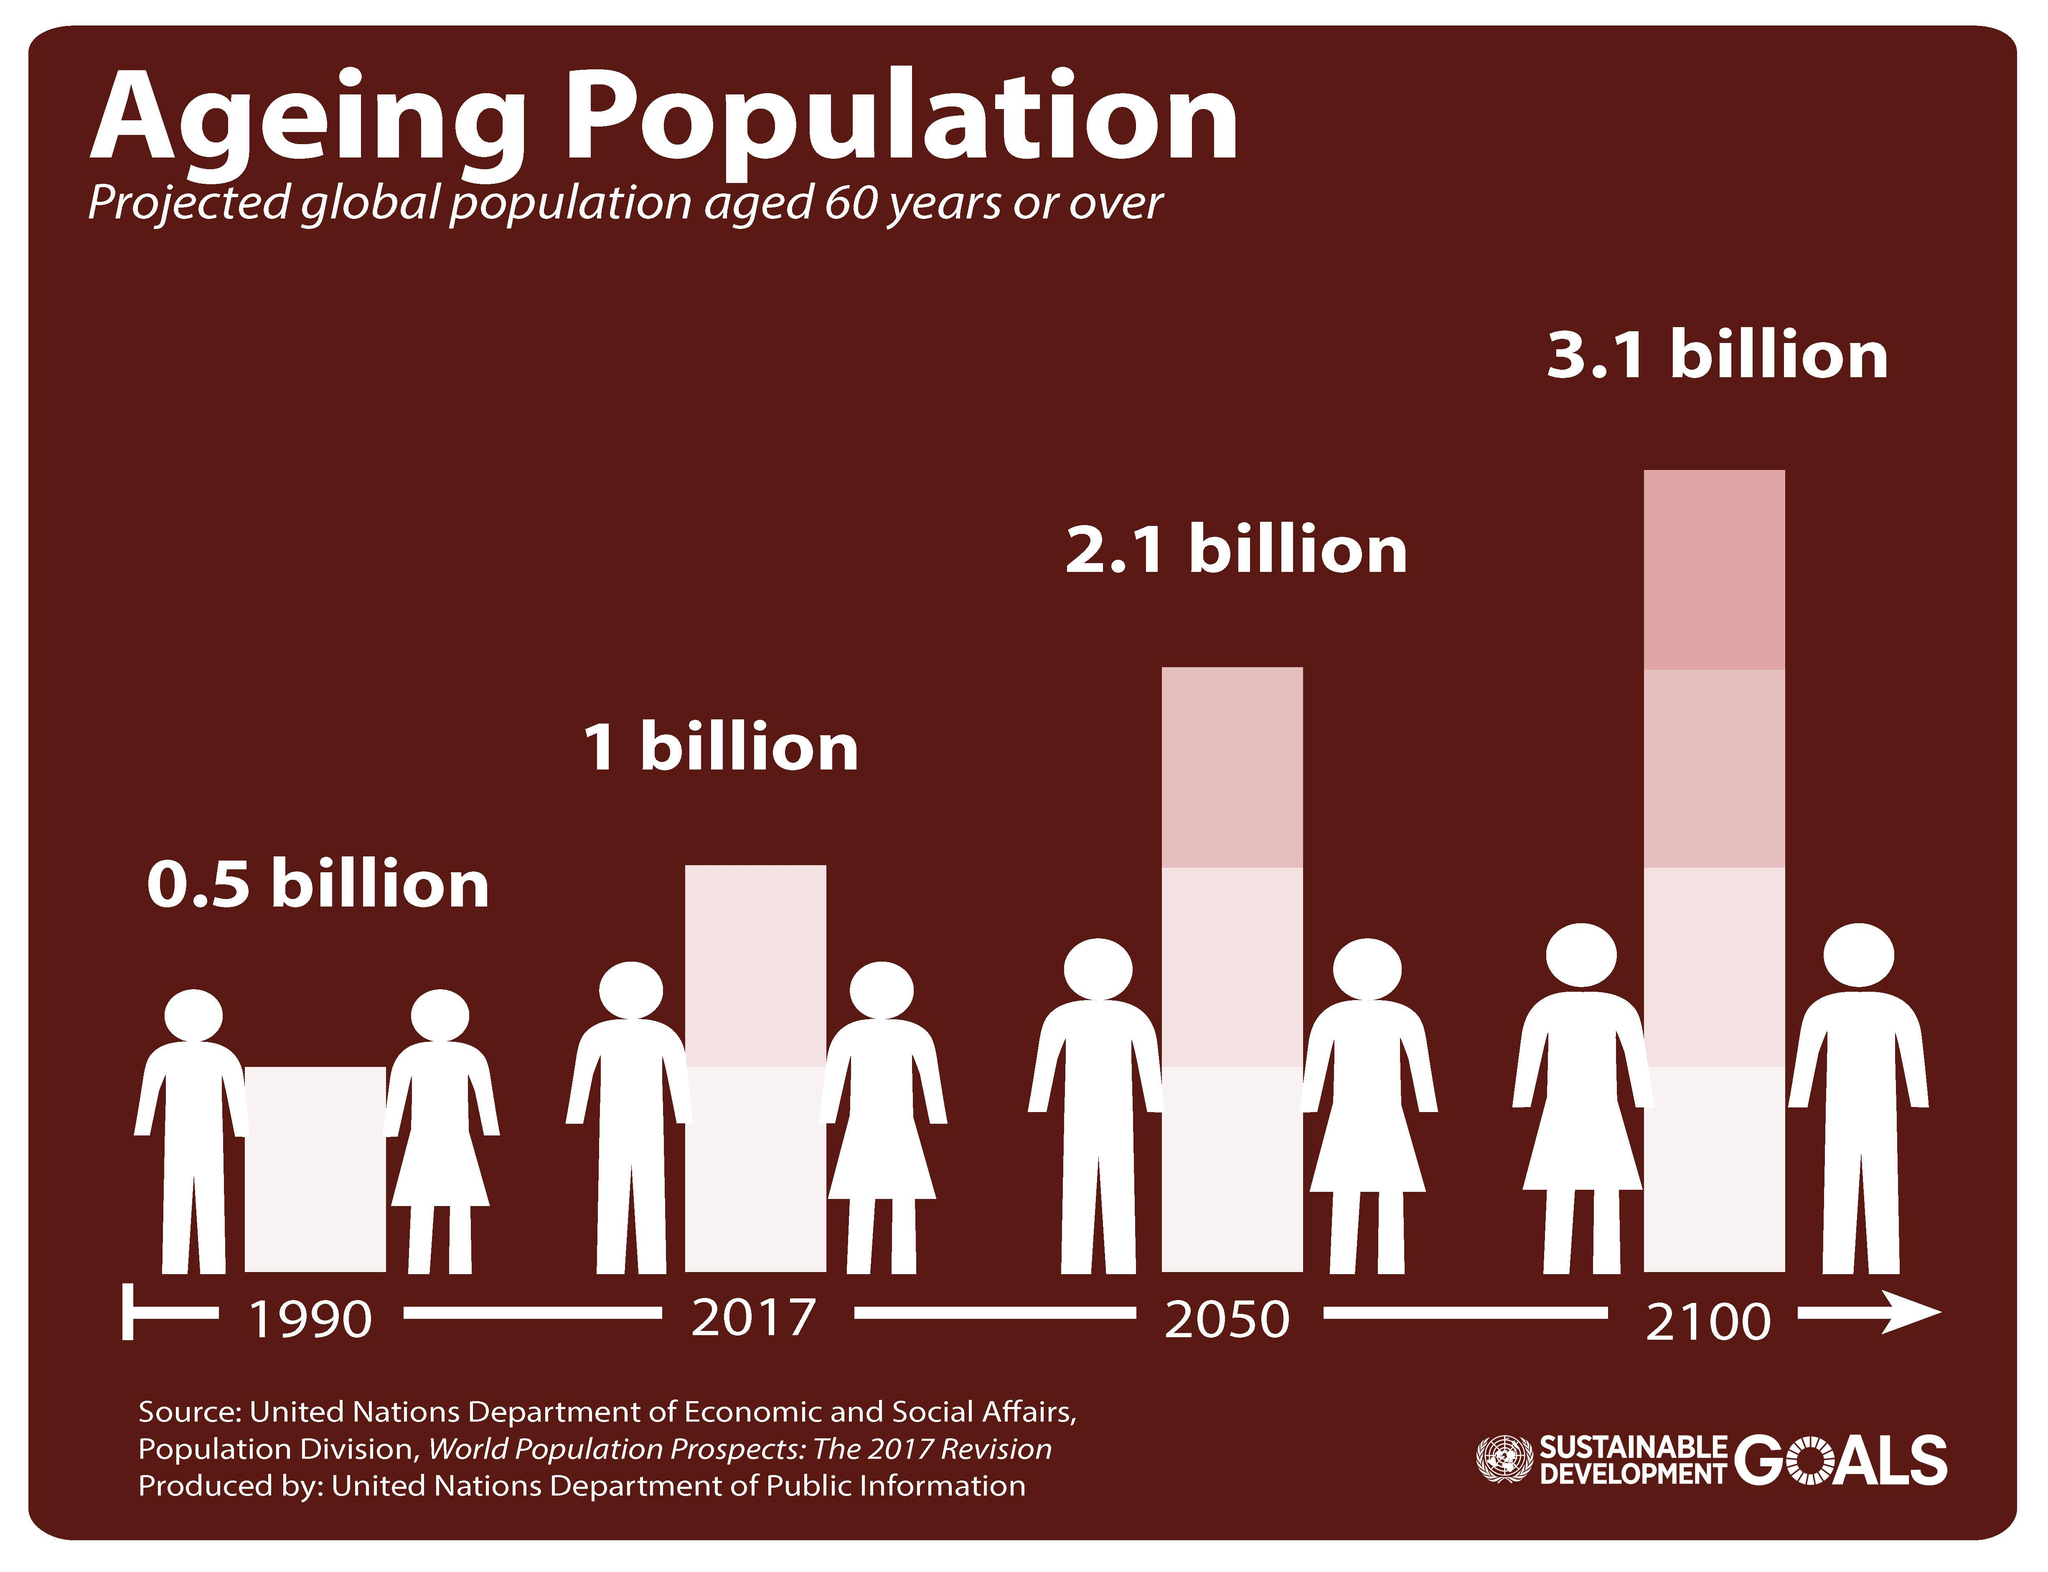Mention a couple of crucial points in this snapshot. In 2100, the aging population is expected to be 2.1 billion larger than it was in 2017. The aging population in 2100 is projected to be one billion higher than the aging population in 2050. According to projections, the difference in the aging population between 2050 and 2017 is expected to be approximately 1.1 billion people. The aging population in 2017 was estimated to be approximately 962 million, while the aging population in 1990 was estimated to be 957 million, indicating a difference of approximately 0.5 billion. In 2100, the aging population will be approximately 2.6 billion larger than it was in 1990. 